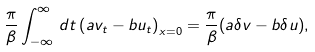Convert formula to latex. <formula><loc_0><loc_0><loc_500><loc_500>\frac { \pi } { \beta } \int _ { - \infty } ^ { \infty } \, d t \left ( a v _ { t } - b u _ { t } \right ) _ { x = 0 } = \frac { \pi } { \beta } ( a \delta v - b \delta u ) ,</formula> 